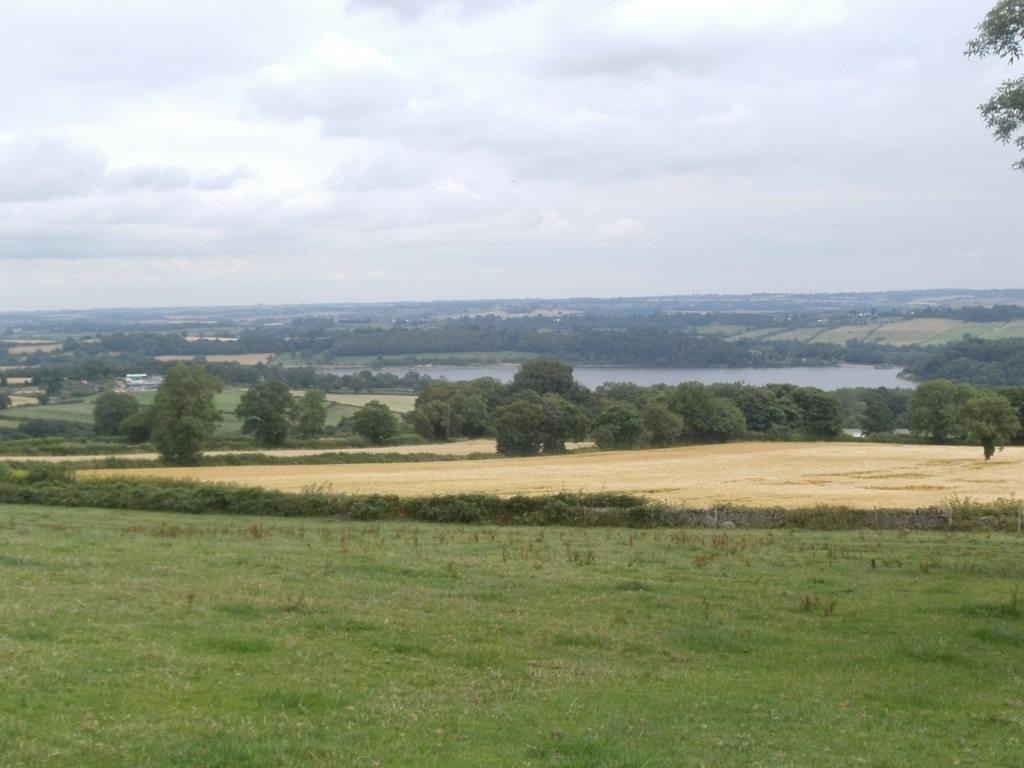In one or two sentences, can you explain what this image depicts? In this picture I can see trees, plants and grass on the ground and I can see water and a cloudy sky. 